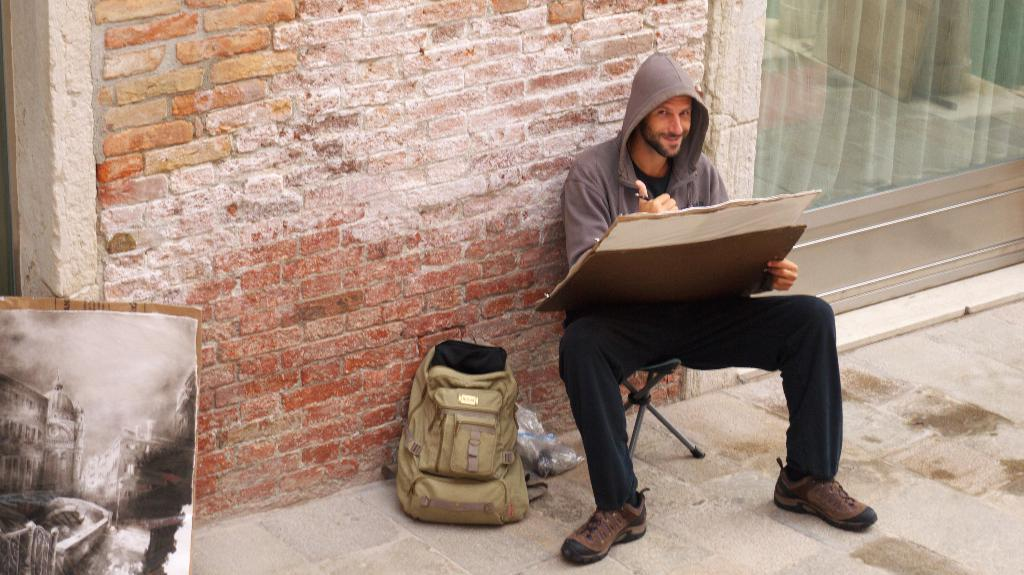Who is present in the image? There is a man in the image. What is the man doing in the image? The man is sitting on a chair. What object is beside the man? There is a bag beside the man. What is the material of the wall in the background? The wall in the background is made of red bricks. What type of shock can be seen affecting the man in the image? There is no shock present in the image; the man is simply sitting on a chair. What type of writing instrument is the man holding in his mouth in the image? There is no writing instrument or any object in the man's mouth in the image. 